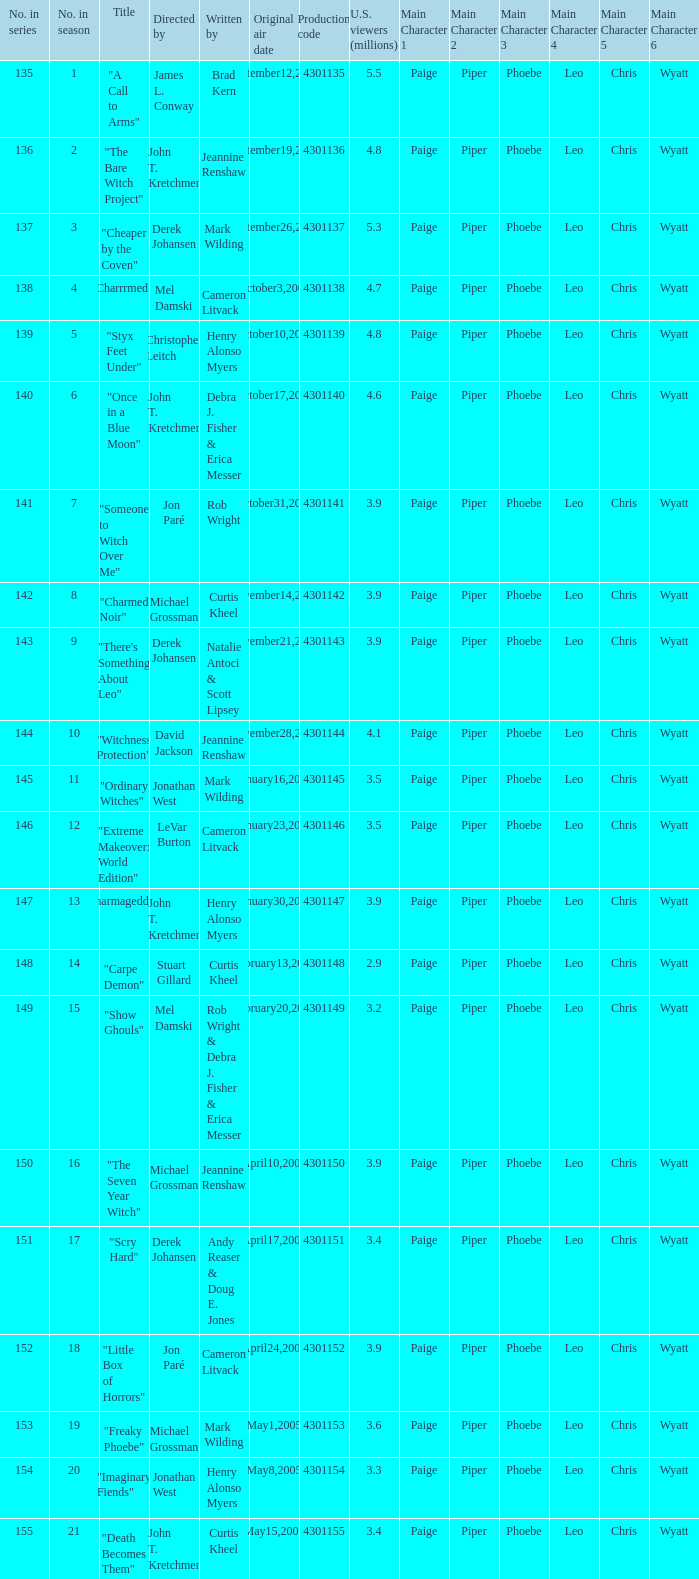Write the full table. {'header': ['No. in series', 'No. in season', 'Title', 'Directed by', 'Written by', 'Original air date', 'Production code', 'U.S. viewers (millions)', 'Main Character 1', 'Main Character 2', 'Main Character 3', 'Main Character 4', 'Main Character 5', 'Main Character 6'], 'rows': [['135', '1', '"A Call to Arms"', 'James L. Conway', 'Brad Kern', 'September12,2004', '4301135', '5.5', 'Paige', 'Piper', 'Phoebe', 'Leo', 'Chris', 'Wyatt'], ['136', '2', '"The Bare Witch Project"', 'John T. Kretchmer', 'Jeannine Renshaw', 'September19,2004', '4301136', '4.8', 'Paige', 'Piper', 'Phoebe', 'Leo', 'Chris', 'Wyatt'], ['137', '3', '"Cheaper by the Coven"', 'Derek Johansen', 'Mark Wilding', 'September26,2004', '4301137', '5.3', 'Paige', 'Piper', 'Phoebe', 'Leo', 'Chris', 'Wyatt'], ['138', '4', '"Charrrmed!"', 'Mel Damski', 'Cameron Litvack', 'October3,2004', '4301138', '4.7', 'Paige', 'Piper', 'Phoebe', 'Leo', 'Chris', 'Wyatt'], ['139', '5', '"Styx Feet Under"', 'Christopher Leitch', 'Henry Alonso Myers', 'October10,2004', '4301139', '4.8', 'Paige', 'Piper', 'Phoebe', 'Leo', 'Chris', 'Wyatt'], ['140', '6', '"Once in a Blue Moon"', 'John T. Kretchmer', 'Debra J. Fisher & Erica Messer', 'October17,2004', '4301140', '4.6', 'Paige', 'Piper', 'Phoebe', 'Leo', 'Chris', 'Wyatt'], ['141', '7', '"Someone to Witch Over Me"', 'Jon Paré', 'Rob Wright', 'October31,2004', '4301141', '3.9', 'Paige', 'Piper', 'Phoebe', 'Leo', 'Chris', 'Wyatt'], ['142', '8', '"Charmed Noir"', 'Michael Grossman', 'Curtis Kheel', 'November14,2004', '4301142', '3.9', 'Paige', 'Piper', 'Phoebe', 'Leo', 'Chris', 'Wyatt'], ['143', '9', '"There\'s Something About Leo"', 'Derek Johansen', 'Natalie Antoci & Scott Lipsey', 'November21,2004', '4301143', '3.9', 'Paige', 'Piper', 'Phoebe', 'Leo', 'Chris', 'Wyatt'], ['144', '10', '"Witchness Protection"', 'David Jackson', 'Jeannine Renshaw', 'November28,2004', '4301144', '4.1', 'Paige', 'Piper', 'Phoebe', 'Leo', 'Chris', 'Wyatt'], ['145', '11', '"Ordinary Witches"', 'Jonathan West', 'Mark Wilding', 'January16,2005', '4301145', '3.5', 'Paige', 'Piper', 'Phoebe', 'Leo', 'Chris', 'Wyatt'], ['146', '12', '"Extreme Makeover: World Edition"', 'LeVar Burton', 'Cameron Litvack', 'January23,2005', '4301146', '3.5', 'Paige', 'Piper', 'Phoebe', 'Leo', 'Chris', 'Wyatt'], ['147', '13', '"Charmageddon"', 'John T. Kretchmer', 'Henry Alonso Myers', 'January30,2005', '4301147', '3.9', 'Paige', 'Piper', 'Phoebe', 'Leo', 'Chris', 'Wyatt'], ['148', '14', '"Carpe Demon"', 'Stuart Gillard', 'Curtis Kheel', 'February13,2005', '4301148', '2.9', 'Paige', 'Piper', 'Phoebe', 'Leo', 'Chris', 'Wyatt'], ['149', '15', '"Show Ghouls"', 'Mel Damski', 'Rob Wright & Debra J. Fisher & Erica Messer', 'February20,2005', '4301149', '3.2', 'Paige', 'Piper', 'Phoebe', 'Leo', 'Chris', 'Wyatt'], ['150', '16', '"The Seven Year Witch"', 'Michael Grossman', 'Jeannine Renshaw', 'April10,2005', '4301150', '3.9', 'Paige', 'Piper', 'Phoebe', 'Leo', 'Chris', 'Wyatt'], ['151', '17', '"Scry Hard"', 'Derek Johansen', 'Andy Reaser & Doug E. Jones', 'April17,2005', '4301151', '3.4', 'Paige', 'Piper', 'Phoebe', 'Leo', 'Chris', 'Wyatt'], ['152', '18', '"Little Box of Horrors"', 'Jon Paré', 'Cameron Litvack', 'April24,2005', '4301152', '3.9', 'Paige', 'Piper', 'Phoebe', 'Leo', 'Chris', 'Wyatt'], ['153', '19', '"Freaky Phoebe"', 'Michael Grossman', 'Mark Wilding', 'May1,2005', '4301153', '3.6', 'Paige', 'Piper', 'Phoebe', 'Leo', 'Chris', 'Wyatt'], ['154', '20', '"Imaginary Fiends"', 'Jonathan West', 'Henry Alonso Myers', 'May8,2005', '4301154', '3.3', 'Paige', 'Piper', 'Phoebe', 'Leo', 'Chris', 'Wyatt'], ['155', '21', '"Death Becomes Them"', 'John T. Kretchmer', 'Curtis Kheel', 'May15,2005', '4301155', '3.4', 'Paige', 'Piper', 'Phoebe', 'Leo', 'Chris', 'Wyatt']]} Who were the directors of the episode called "someone to witch over me"? Jon Paré. 